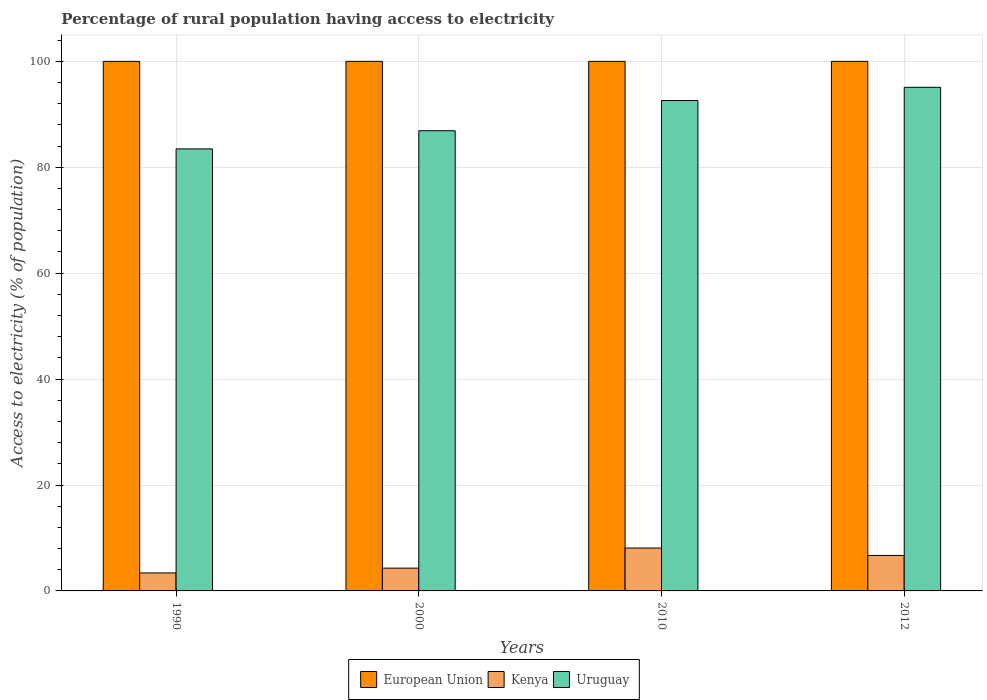How many different coloured bars are there?
Give a very brief answer. 3. Are the number of bars per tick equal to the number of legend labels?
Make the answer very short. Yes. What is the label of the 2nd group of bars from the left?
Offer a terse response. 2000. Across all years, what is the maximum percentage of rural population having access to electricity in European Union?
Provide a succinct answer. 100. Across all years, what is the minimum percentage of rural population having access to electricity in Kenya?
Your response must be concise. 3.4. In which year was the percentage of rural population having access to electricity in Uruguay minimum?
Your answer should be compact. 1990. What is the total percentage of rural population having access to electricity in Uruguay in the graph?
Offer a very short reply. 358.07. What is the difference between the percentage of rural population having access to electricity in Uruguay in 2000 and the percentage of rural population having access to electricity in European Union in 1990?
Provide a short and direct response. -13.09. What is the average percentage of rural population having access to electricity in Uruguay per year?
Your answer should be compact. 89.52. In the year 1990, what is the difference between the percentage of rural population having access to electricity in Kenya and percentage of rural population having access to electricity in Uruguay?
Ensure brevity in your answer.  -80.07. In how many years, is the percentage of rural population having access to electricity in Uruguay greater than 4 %?
Keep it short and to the point. 4. What is the ratio of the percentage of rural population having access to electricity in Kenya in 2000 to that in 2012?
Your answer should be very brief. 0.64. Is the percentage of rural population having access to electricity in Uruguay in 2000 less than that in 2012?
Give a very brief answer. Yes. Is the difference between the percentage of rural population having access to electricity in Kenya in 1990 and 2012 greater than the difference between the percentage of rural population having access to electricity in Uruguay in 1990 and 2012?
Your response must be concise. Yes. What is the difference between the highest and the second highest percentage of rural population having access to electricity in Kenya?
Provide a succinct answer. 1.4. What is the difference between the highest and the lowest percentage of rural population having access to electricity in Uruguay?
Your answer should be compact. 11.63. In how many years, is the percentage of rural population having access to electricity in European Union greater than the average percentage of rural population having access to electricity in European Union taken over all years?
Your response must be concise. 3. Is the sum of the percentage of rural population having access to electricity in Kenya in 1990 and 2012 greater than the maximum percentage of rural population having access to electricity in Uruguay across all years?
Provide a succinct answer. No. What does the 1st bar from the left in 2000 represents?
Offer a terse response. European Union. What does the 3rd bar from the right in 2012 represents?
Offer a terse response. European Union. How many years are there in the graph?
Provide a short and direct response. 4. Are the values on the major ticks of Y-axis written in scientific E-notation?
Your answer should be compact. No. Does the graph contain any zero values?
Offer a very short reply. No. Does the graph contain grids?
Ensure brevity in your answer.  Yes. Where does the legend appear in the graph?
Offer a terse response. Bottom center. What is the title of the graph?
Provide a short and direct response. Percentage of rural population having access to electricity. What is the label or title of the Y-axis?
Your answer should be compact. Access to electricity (% of population). What is the Access to electricity (% of population) in European Union in 1990?
Keep it short and to the point. 99.99. What is the Access to electricity (% of population) in Uruguay in 1990?
Give a very brief answer. 83.47. What is the Access to electricity (% of population) in Kenya in 2000?
Give a very brief answer. 4.3. What is the Access to electricity (% of population) of Uruguay in 2000?
Offer a terse response. 86.9. What is the Access to electricity (% of population) of Uruguay in 2010?
Ensure brevity in your answer.  92.6. What is the Access to electricity (% of population) in Uruguay in 2012?
Make the answer very short. 95.1. Across all years, what is the maximum Access to electricity (% of population) in Uruguay?
Offer a terse response. 95.1. Across all years, what is the minimum Access to electricity (% of population) of European Union?
Offer a terse response. 99.99. Across all years, what is the minimum Access to electricity (% of population) of Uruguay?
Provide a succinct answer. 83.47. What is the total Access to electricity (% of population) in European Union in the graph?
Offer a terse response. 399.99. What is the total Access to electricity (% of population) of Uruguay in the graph?
Give a very brief answer. 358.07. What is the difference between the Access to electricity (% of population) in European Union in 1990 and that in 2000?
Make the answer very short. -0.01. What is the difference between the Access to electricity (% of population) of Kenya in 1990 and that in 2000?
Provide a succinct answer. -0.9. What is the difference between the Access to electricity (% of population) in Uruguay in 1990 and that in 2000?
Give a very brief answer. -3.43. What is the difference between the Access to electricity (% of population) of European Union in 1990 and that in 2010?
Keep it short and to the point. -0.01. What is the difference between the Access to electricity (% of population) in Kenya in 1990 and that in 2010?
Your answer should be compact. -4.7. What is the difference between the Access to electricity (% of population) in Uruguay in 1990 and that in 2010?
Your response must be concise. -9.13. What is the difference between the Access to electricity (% of population) of European Union in 1990 and that in 2012?
Provide a short and direct response. -0.01. What is the difference between the Access to electricity (% of population) in Uruguay in 1990 and that in 2012?
Your answer should be very brief. -11.63. What is the difference between the Access to electricity (% of population) of European Union in 2000 and that in 2010?
Your answer should be very brief. 0. What is the difference between the Access to electricity (% of population) in Uruguay in 2000 and that in 2010?
Your response must be concise. -5.7. What is the difference between the Access to electricity (% of population) in Kenya in 2000 and that in 2012?
Your answer should be compact. -2.4. What is the difference between the Access to electricity (% of population) in Uruguay in 2000 and that in 2012?
Offer a terse response. -8.2. What is the difference between the Access to electricity (% of population) in European Union in 2010 and that in 2012?
Offer a terse response. 0. What is the difference between the Access to electricity (% of population) of European Union in 1990 and the Access to electricity (% of population) of Kenya in 2000?
Give a very brief answer. 95.69. What is the difference between the Access to electricity (% of population) in European Union in 1990 and the Access to electricity (% of population) in Uruguay in 2000?
Your response must be concise. 13.09. What is the difference between the Access to electricity (% of population) in Kenya in 1990 and the Access to electricity (% of population) in Uruguay in 2000?
Your response must be concise. -83.5. What is the difference between the Access to electricity (% of population) in European Union in 1990 and the Access to electricity (% of population) in Kenya in 2010?
Your answer should be very brief. 91.89. What is the difference between the Access to electricity (% of population) of European Union in 1990 and the Access to electricity (% of population) of Uruguay in 2010?
Offer a terse response. 7.39. What is the difference between the Access to electricity (% of population) of Kenya in 1990 and the Access to electricity (% of population) of Uruguay in 2010?
Provide a short and direct response. -89.2. What is the difference between the Access to electricity (% of population) in European Union in 1990 and the Access to electricity (% of population) in Kenya in 2012?
Your answer should be compact. 93.29. What is the difference between the Access to electricity (% of population) in European Union in 1990 and the Access to electricity (% of population) in Uruguay in 2012?
Provide a short and direct response. 4.89. What is the difference between the Access to electricity (% of population) of Kenya in 1990 and the Access to electricity (% of population) of Uruguay in 2012?
Make the answer very short. -91.7. What is the difference between the Access to electricity (% of population) in European Union in 2000 and the Access to electricity (% of population) in Kenya in 2010?
Make the answer very short. 91.9. What is the difference between the Access to electricity (% of population) in Kenya in 2000 and the Access to electricity (% of population) in Uruguay in 2010?
Provide a succinct answer. -88.3. What is the difference between the Access to electricity (% of population) of European Union in 2000 and the Access to electricity (% of population) of Kenya in 2012?
Keep it short and to the point. 93.3. What is the difference between the Access to electricity (% of population) of European Union in 2000 and the Access to electricity (% of population) of Uruguay in 2012?
Offer a terse response. 4.9. What is the difference between the Access to electricity (% of population) of Kenya in 2000 and the Access to electricity (% of population) of Uruguay in 2012?
Your answer should be very brief. -90.8. What is the difference between the Access to electricity (% of population) in European Union in 2010 and the Access to electricity (% of population) in Kenya in 2012?
Your response must be concise. 93.3. What is the difference between the Access to electricity (% of population) of European Union in 2010 and the Access to electricity (% of population) of Uruguay in 2012?
Offer a terse response. 4.9. What is the difference between the Access to electricity (% of population) in Kenya in 2010 and the Access to electricity (% of population) in Uruguay in 2012?
Provide a succinct answer. -87. What is the average Access to electricity (% of population) of European Union per year?
Make the answer very short. 100. What is the average Access to electricity (% of population) of Kenya per year?
Offer a terse response. 5.62. What is the average Access to electricity (% of population) of Uruguay per year?
Make the answer very short. 89.52. In the year 1990, what is the difference between the Access to electricity (% of population) of European Union and Access to electricity (% of population) of Kenya?
Ensure brevity in your answer.  96.59. In the year 1990, what is the difference between the Access to electricity (% of population) of European Union and Access to electricity (% of population) of Uruguay?
Offer a terse response. 16.52. In the year 1990, what is the difference between the Access to electricity (% of population) in Kenya and Access to electricity (% of population) in Uruguay?
Your answer should be compact. -80.07. In the year 2000, what is the difference between the Access to electricity (% of population) in European Union and Access to electricity (% of population) in Kenya?
Your response must be concise. 95.7. In the year 2000, what is the difference between the Access to electricity (% of population) in European Union and Access to electricity (% of population) in Uruguay?
Ensure brevity in your answer.  13.1. In the year 2000, what is the difference between the Access to electricity (% of population) of Kenya and Access to electricity (% of population) of Uruguay?
Ensure brevity in your answer.  -82.6. In the year 2010, what is the difference between the Access to electricity (% of population) of European Union and Access to electricity (% of population) of Kenya?
Provide a short and direct response. 91.9. In the year 2010, what is the difference between the Access to electricity (% of population) in European Union and Access to electricity (% of population) in Uruguay?
Offer a very short reply. 7.4. In the year 2010, what is the difference between the Access to electricity (% of population) of Kenya and Access to electricity (% of population) of Uruguay?
Ensure brevity in your answer.  -84.5. In the year 2012, what is the difference between the Access to electricity (% of population) in European Union and Access to electricity (% of population) in Kenya?
Provide a succinct answer. 93.3. In the year 2012, what is the difference between the Access to electricity (% of population) of European Union and Access to electricity (% of population) of Uruguay?
Your answer should be very brief. 4.9. In the year 2012, what is the difference between the Access to electricity (% of population) of Kenya and Access to electricity (% of population) of Uruguay?
Your answer should be compact. -88.4. What is the ratio of the Access to electricity (% of population) in European Union in 1990 to that in 2000?
Provide a short and direct response. 1. What is the ratio of the Access to electricity (% of population) in Kenya in 1990 to that in 2000?
Your answer should be very brief. 0.79. What is the ratio of the Access to electricity (% of population) in Uruguay in 1990 to that in 2000?
Provide a succinct answer. 0.96. What is the ratio of the Access to electricity (% of population) of Kenya in 1990 to that in 2010?
Your answer should be very brief. 0.42. What is the ratio of the Access to electricity (% of population) in Uruguay in 1990 to that in 2010?
Your answer should be compact. 0.9. What is the ratio of the Access to electricity (% of population) of Kenya in 1990 to that in 2012?
Give a very brief answer. 0.51. What is the ratio of the Access to electricity (% of population) in Uruguay in 1990 to that in 2012?
Offer a terse response. 0.88. What is the ratio of the Access to electricity (% of population) of Kenya in 2000 to that in 2010?
Give a very brief answer. 0.53. What is the ratio of the Access to electricity (% of population) in Uruguay in 2000 to that in 2010?
Your response must be concise. 0.94. What is the ratio of the Access to electricity (% of population) of Kenya in 2000 to that in 2012?
Make the answer very short. 0.64. What is the ratio of the Access to electricity (% of population) in Uruguay in 2000 to that in 2012?
Your response must be concise. 0.91. What is the ratio of the Access to electricity (% of population) in Kenya in 2010 to that in 2012?
Ensure brevity in your answer.  1.21. What is the ratio of the Access to electricity (% of population) in Uruguay in 2010 to that in 2012?
Ensure brevity in your answer.  0.97. What is the difference between the highest and the lowest Access to electricity (% of population) of European Union?
Ensure brevity in your answer.  0.01. What is the difference between the highest and the lowest Access to electricity (% of population) in Kenya?
Your answer should be compact. 4.7. What is the difference between the highest and the lowest Access to electricity (% of population) of Uruguay?
Your response must be concise. 11.63. 